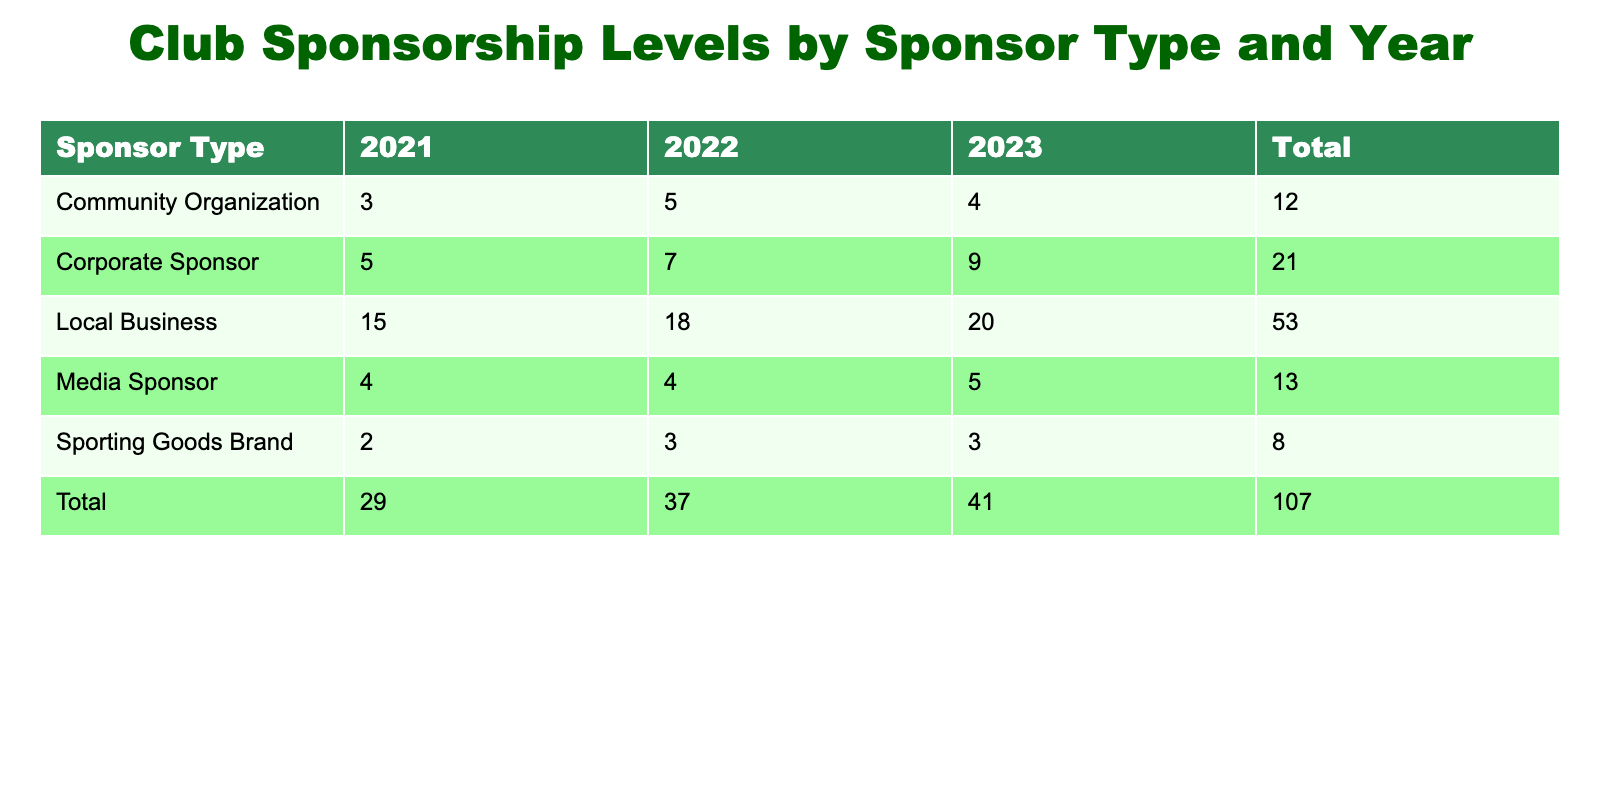What is the total number of sponsors in 2022? To find the total number of sponsors in 2022, we need to sum up the number of sponsors for each sponsor type listed for that year: Local Business (18) + Corporate Sponsor (7) + Community Organization (5) + Sporting Goods Brand (3) + Media Sponsor (4) = 37. Therefore, the total number of sponsors in 2022 is 37.
Answer: 37 How many sponsors were there for Community Organizations in 2021? The number of sponsors for Community Organizations in 2021 is explicitly listed in the table as 3.
Answer: 3 Did the number of Corporate Sponsors increase from 2021 to 2023? In 2021, there were 5 Corporate Sponsors, and in 2023, there were 9. This indicates an increase because 9 is greater than 5.
Answer: Yes What is the average number of sponsors for Local Businesses over the three years? The number of sponsors for Local Businesses over the three years is as follows: 2021 (15), 2022 (18), and 2023 (20). We first sum these numbers: 15 + 18 + 20 = 53. Then, we divide by the number of years, which is 3: 53 / 3 = approximately 17.67, so the average is 17.67.
Answer: 17.67 What sponsor type had the highest total number of sponsors across all years? We need to calculate the total number of sponsors for each sponsor type: Local Business (15 + 18 + 20 = 53), Corporate Sponsor (5 + 7 + 9 = 21), Community Organization (3 + 5 + 4 = 12), Sporting Goods Brand (2 + 3 + 3 = 8), Media Sponsor (4 + 4 + 5 = 13). The highest total is Local Business with 53.
Answer: Local Business 